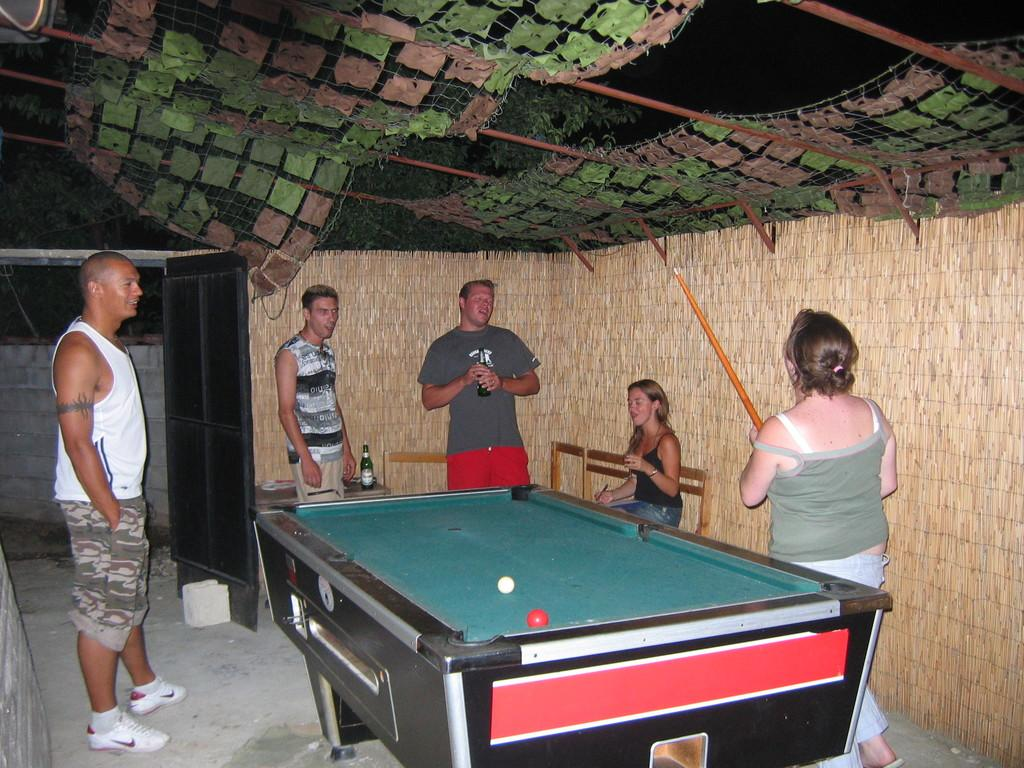What is the woman holding in the image? The woman is holding a snooker stick. What is located near the woman? There is a snooker table beside the woman. Can you describe the group of people in the image? There is a group of people standing in front of the woman. What type of bath can be seen in the image? There is no bath present in the image; it features a woman holding a snooker stick and a snooker table. Can you describe the bat that is flying around in the image? There is no bat present in the image; it is focused on a woman holding a snooker stick and a snooker table. 